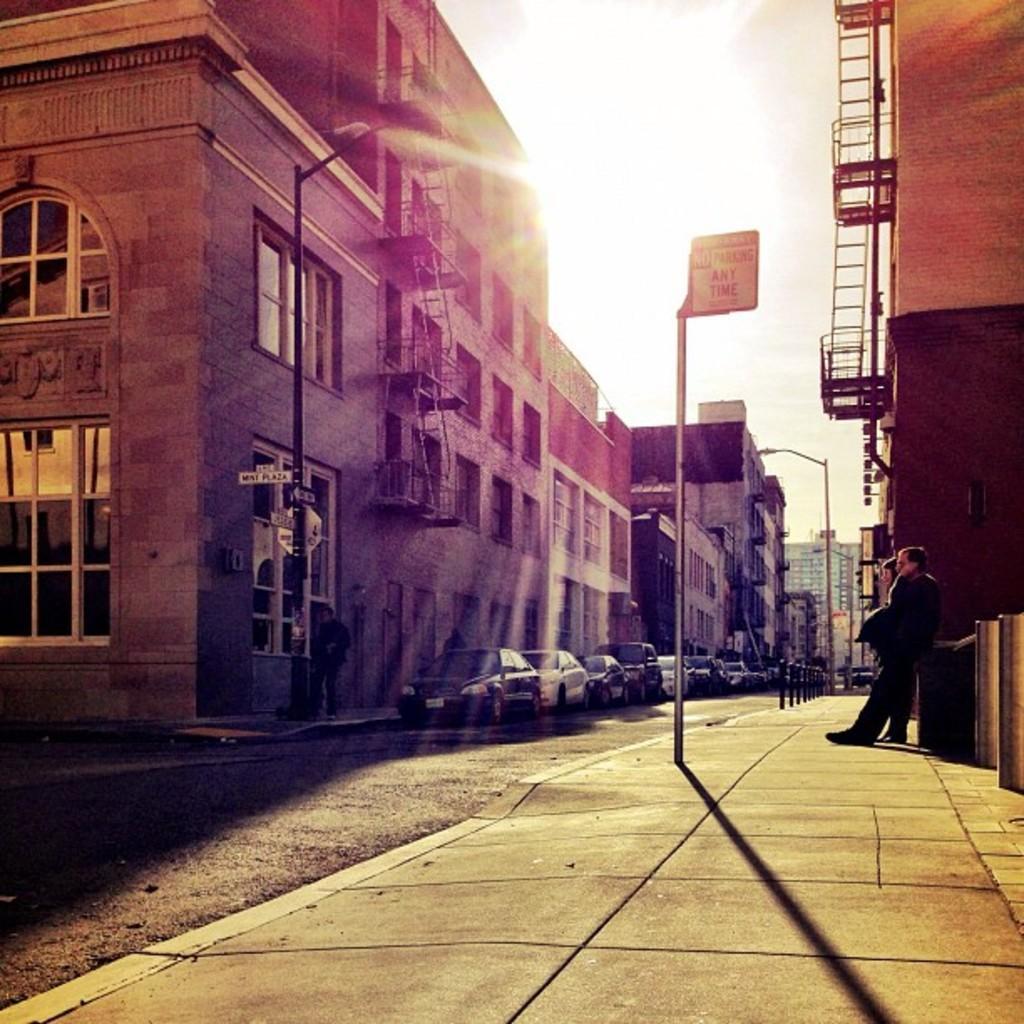Can you describe this image briefly? In this image I can see buildings , in front of the buildings I can see vehicles parking on the road and I can see a signboard visible in the middle , on the right side I can see two persons standing in front of the wall, at the top I can see the sky, 